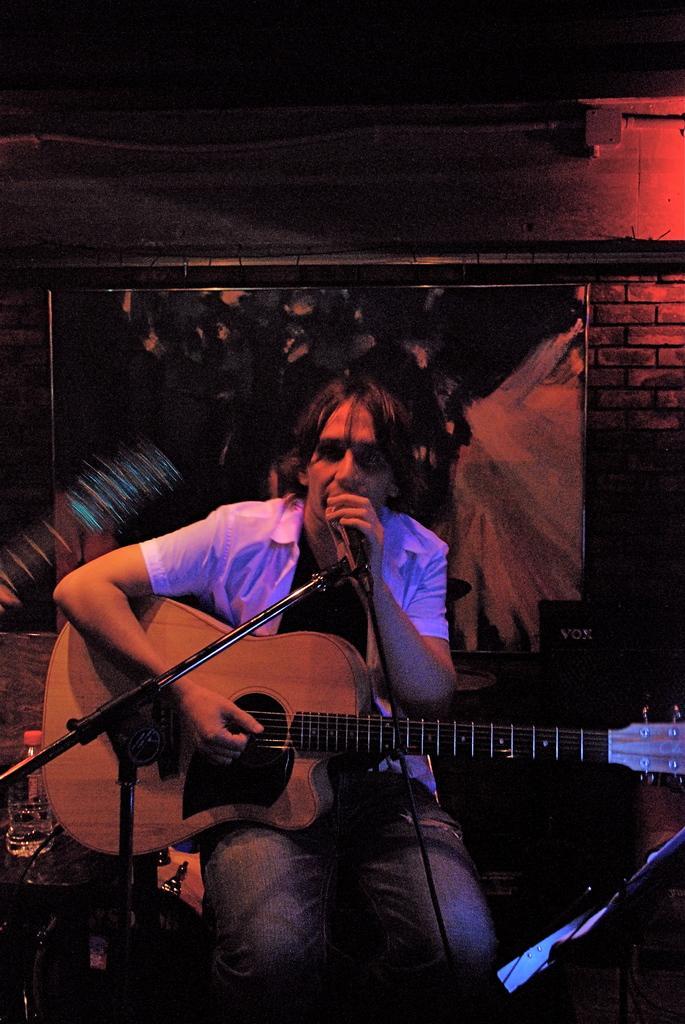How would you summarize this image in a sentence or two? A person in the dark room who is holding a microphone and a guitar and also behind him a wall poster on the bricks wall. And also have some wire line connection. 